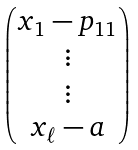Convert formula to latex. <formula><loc_0><loc_0><loc_500><loc_500>\begin{pmatrix} x _ { 1 } - p _ { 1 1 } \\ \vdots \\ \vdots \\ x _ { \ell } - a \\ \end{pmatrix}</formula> 